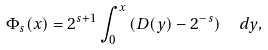Convert formula to latex. <formula><loc_0><loc_0><loc_500><loc_500>\Phi _ { s } ( x ) = 2 ^ { s + 1 } \int _ { 0 } ^ { x } \left ( D ( y ) - 2 ^ { - s } \right ) \ \ d y ,</formula> 